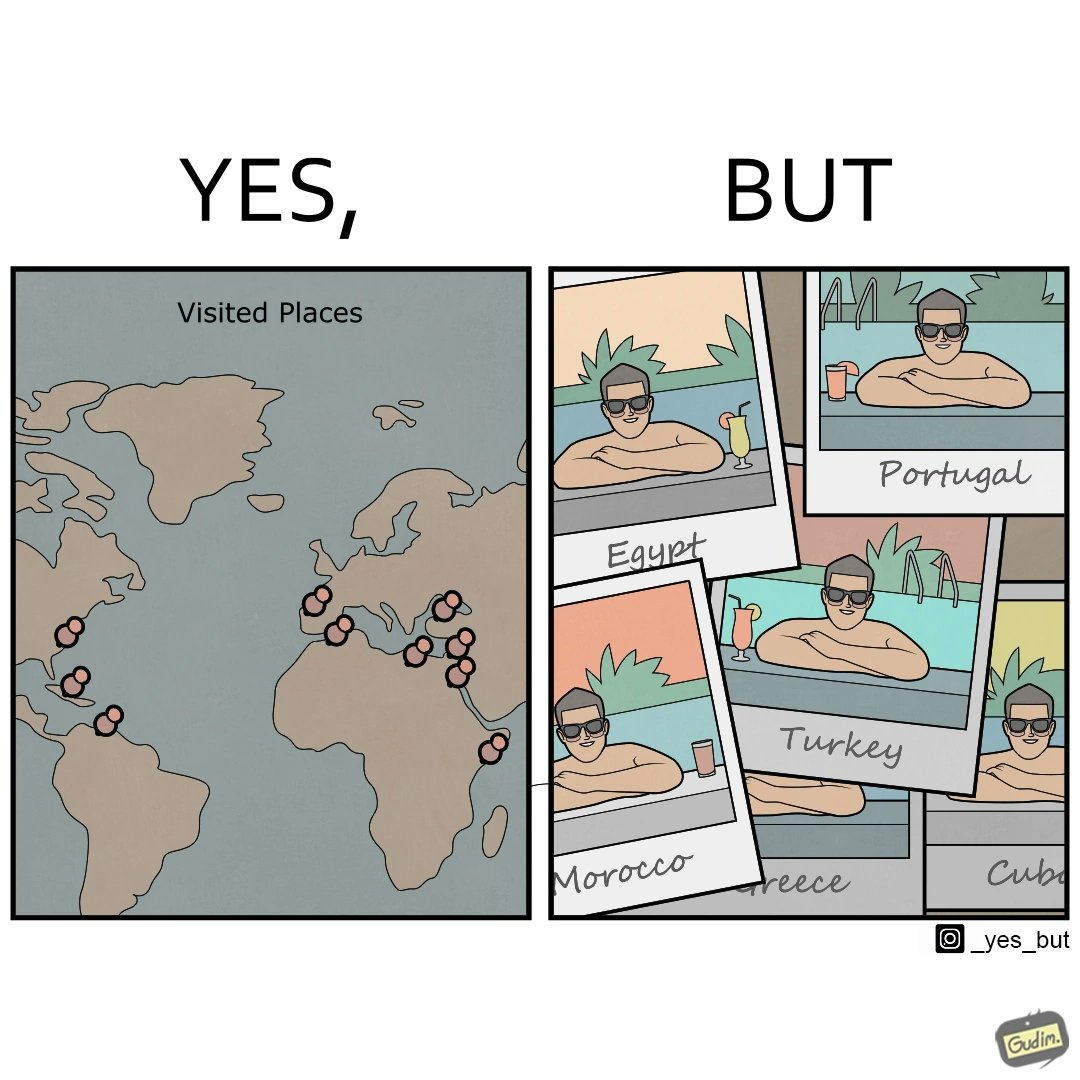Is there satirical content in this image? Yes, this image is satirical. 